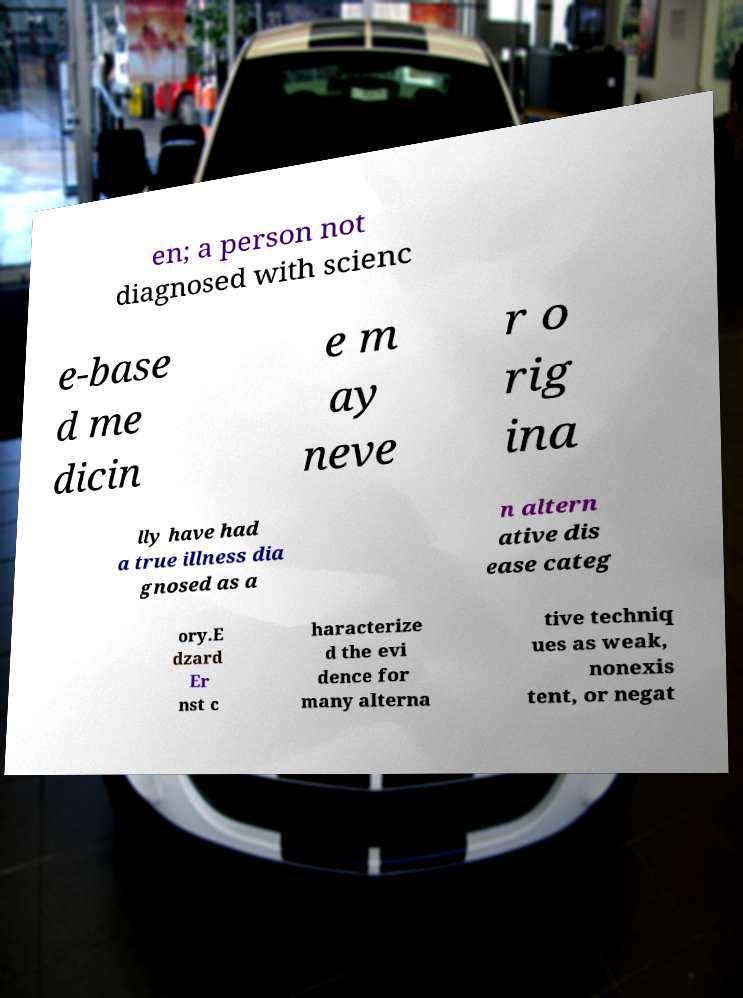There's text embedded in this image that I need extracted. Can you transcribe it verbatim? en; a person not diagnosed with scienc e-base d me dicin e m ay neve r o rig ina lly have had a true illness dia gnosed as a n altern ative dis ease categ ory.E dzard Er nst c haracterize d the evi dence for many alterna tive techniq ues as weak, nonexis tent, or negat 